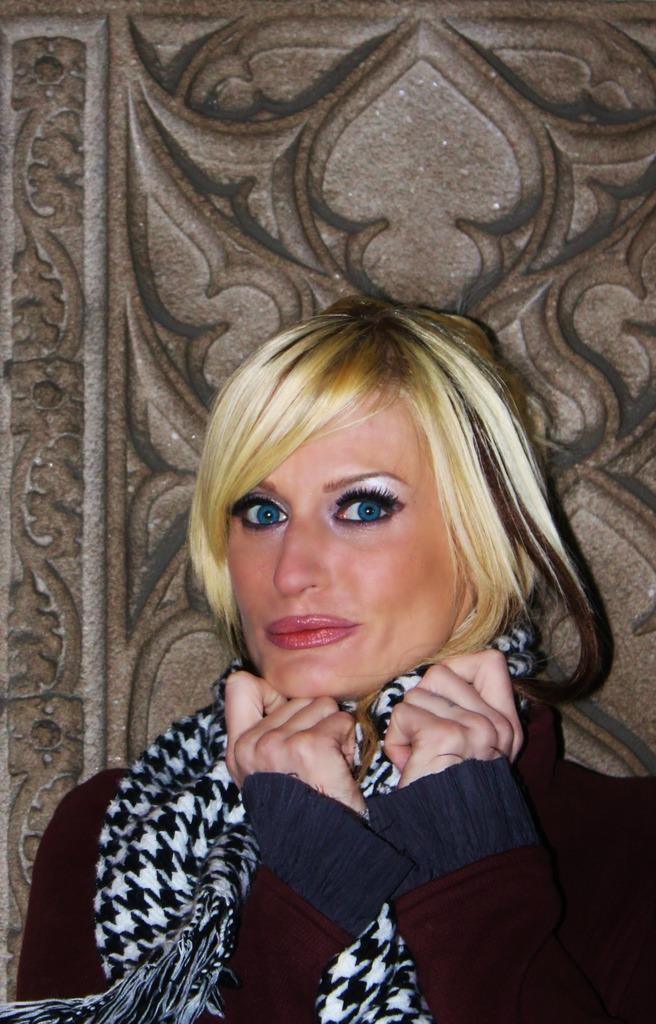Who is present in the image? There is a woman in the image. What is the woman wearing? The woman is wearing a jacket. What is the woman doing in the image? The woman is looking at a picture. What type of accessory is on her shoulder? There is a neck wear on her shoulder. What can be seen in the background of the image? There is a rock visible at the back of the woman. What color is the orange in the image? There is no orange present in the image. Is the woman swimming in the image? The image does not show the woman swimming; she is looking at a picture. 